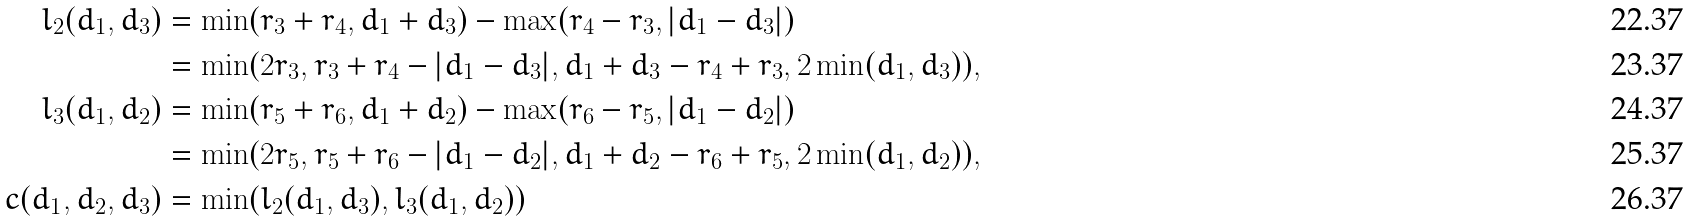Convert formula to latex. <formula><loc_0><loc_0><loc_500><loc_500>l _ { 2 } ( d _ { 1 } , d _ { 3 } ) & = \min ( r _ { 3 } + r _ { 4 } , d _ { 1 } + d _ { 3 } ) - \max ( r _ { 4 } - r _ { 3 } , | d _ { 1 } - d _ { 3 } | ) \\ & = \min ( 2 r _ { 3 } , r _ { 3 } + r _ { 4 } - | d _ { 1 } - d _ { 3 } | , d _ { 1 } + d _ { 3 } - r _ { 4 } + r _ { 3 } , 2 \min ( d _ { 1 } , d _ { 3 } ) ) , \\ l _ { 3 } ( d _ { 1 } , d _ { 2 } ) & = \min ( r _ { 5 } + r _ { 6 } , d _ { 1 } + d _ { 2 } ) - \max ( r _ { 6 } - r _ { 5 } , | d _ { 1 } - d _ { 2 } | ) \\ & = \min ( 2 r _ { 5 } , r _ { 5 } + r _ { 6 } - | d _ { 1 } - d _ { 2 } | , d _ { 1 } + d _ { 2 } - r _ { 6 } + r _ { 5 } , 2 \min ( d _ { 1 } , d _ { 2 } ) ) , \\ c ( d _ { 1 } , d _ { 2 } , d _ { 3 } ) & = \min ( l _ { 2 } ( d _ { 1 } , d _ { 3 } ) , l _ { 3 } ( d _ { 1 } , d _ { 2 } ) )</formula> 